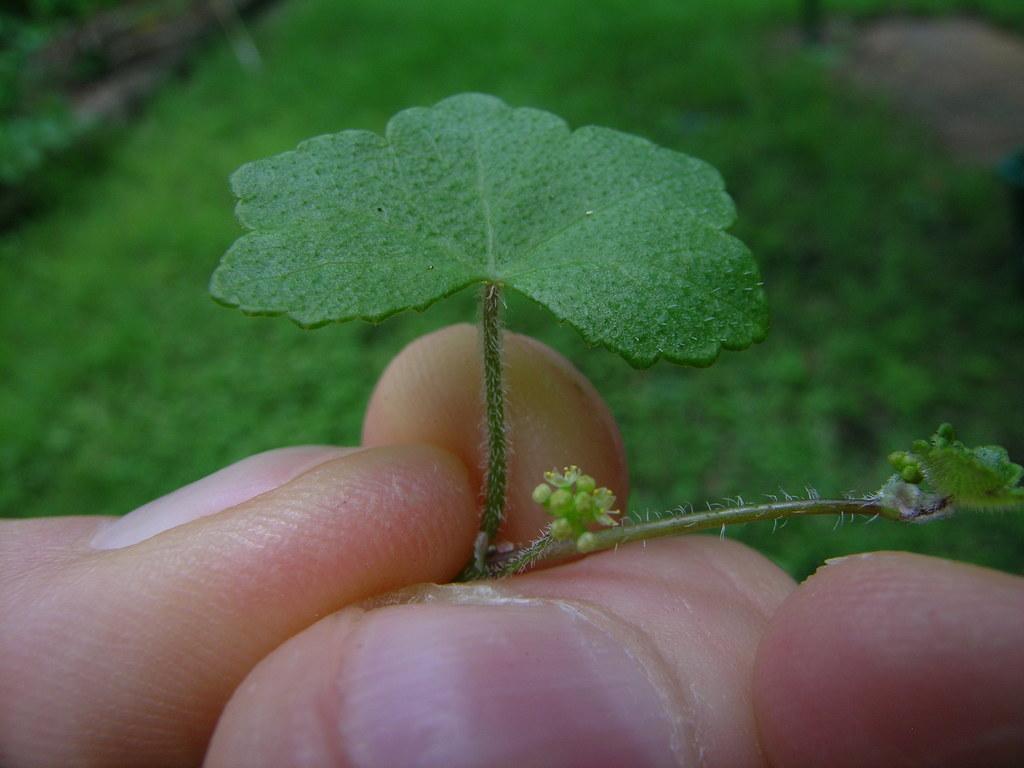How would you summarize this image in a sentence or two? In this image we can see a grassy land in the image. There is are few plants in the image. We can see a person's finger in the image. A person is holding a leaf of the plant in the image. 